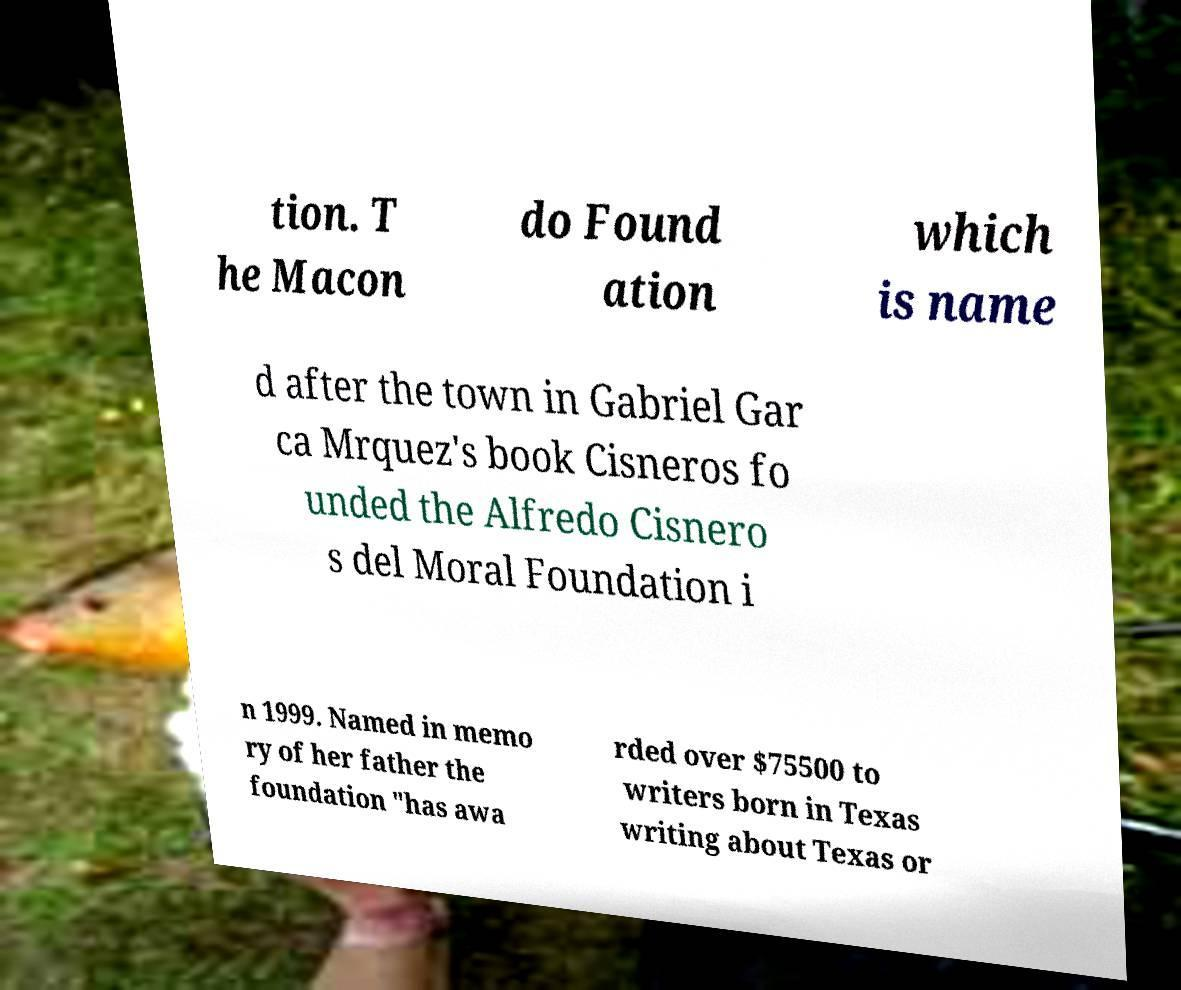Can you read and provide the text displayed in the image?This photo seems to have some interesting text. Can you extract and type it out for me? tion. T he Macon do Found ation which is name d after the town in Gabriel Gar ca Mrquez's book Cisneros fo unded the Alfredo Cisnero s del Moral Foundation i n 1999. Named in memo ry of her father the foundation "has awa rded over $75500 to writers born in Texas writing about Texas or 